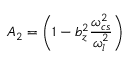<formula> <loc_0><loc_0><loc_500><loc_500>A _ { 2 } = \left ( 1 - b _ { z } ^ { 2 } \frac { \omega _ { c s } ^ { 2 } } { \omega _ { l } ^ { 2 } } \right )</formula> 